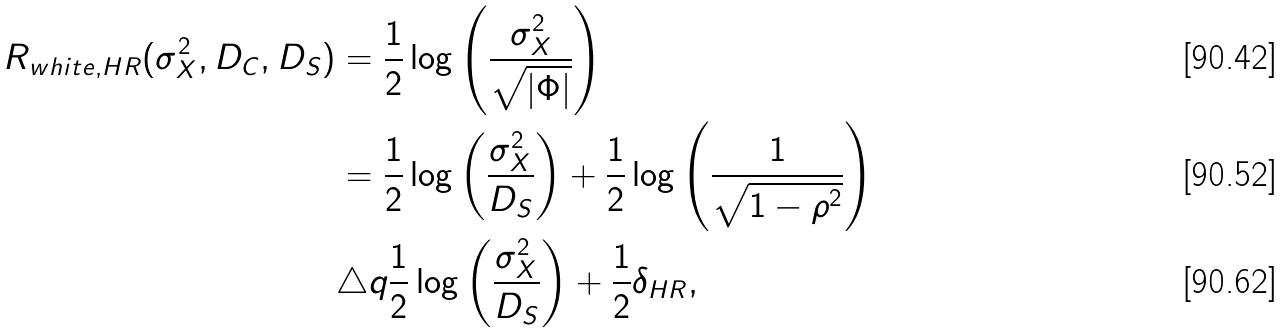Convert formula to latex. <formula><loc_0><loc_0><loc_500><loc_500>R _ { w h i t e , H R } ( \sigma _ { X } ^ { 2 } , D _ { C } , D _ { S } ) & = \frac { 1 } { 2 } \log \left ( \frac { \sigma _ { X } ^ { 2 } } { \sqrt { | \Phi | } } \right ) \\ & = \frac { 1 } { 2 } \log \left ( \frac { \sigma _ { X } ^ { 2 } } { D _ { S } } \right ) + \frac { 1 } { 2 } \log \left ( \frac { 1 } { \sqrt { 1 - \rho ^ { 2 } } } \right ) \\ & \triangle q \frac { 1 } { 2 } \log \left ( \frac { \sigma _ { X } ^ { 2 } } { D _ { S } } \right ) + \frac { 1 } { 2 } \delta _ { H R } ,</formula> 